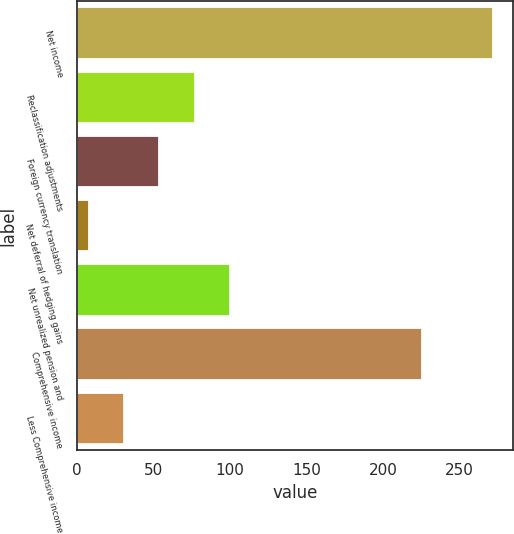Convert chart to OTSL. <chart><loc_0><loc_0><loc_500><loc_500><bar_chart><fcel>Net income<fcel>Reclassification adjustments<fcel>Foreign currency translation<fcel>Net deferral of hedging gains<fcel>Net unrealized pension and<fcel>Comprehensive income<fcel>Less Comprehensive income<nl><fcel>271.64<fcel>76.96<fcel>53.84<fcel>7.6<fcel>100.08<fcel>225.4<fcel>30.72<nl></chart> 